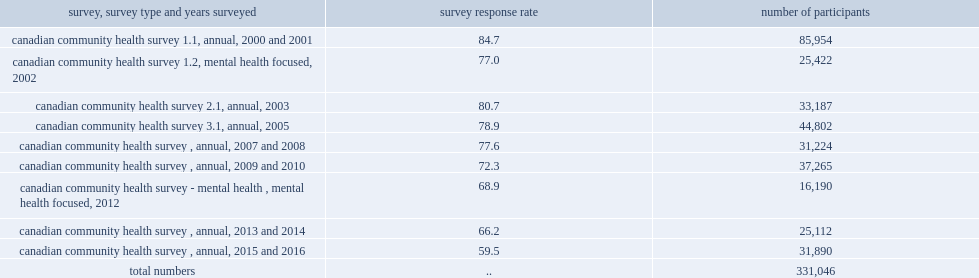How many participants were included after the study criteria were applied. 331046.0. 